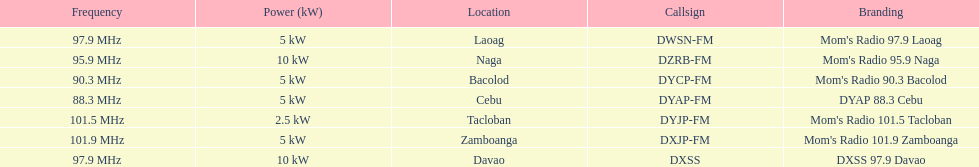How many kw was the radio in davao? 10 kW. 